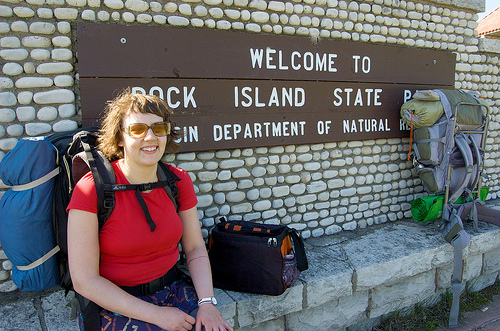<image>
Is there a woman next to the bag? Yes. The woman is positioned adjacent to the bag, located nearby in the same general area. Is there a bag on the women? No. The bag is not positioned on the women. They may be near each other, but the bag is not supported by or resting on top of the women. Is there a woman in front of the bag? No. The woman is not in front of the bag. The spatial positioning shows a different relationship between these objects. Where is the sign in relation to the woman? Is it in front of the woman? No. The sign is not in front of the woman. The spatial positioning shows a different relationship between these objects. 